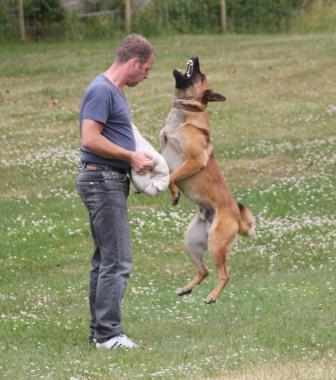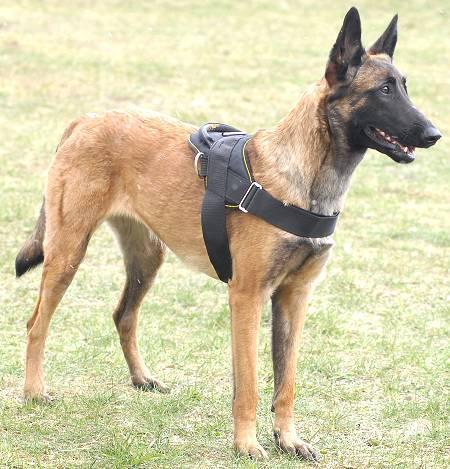The first image is the image on the left, the second image is the image on the right. Considering the images on both sides, is "a dog is laying in the grass with a leash on" valid? Answer yes or no. No. The first image is the image on the left, the second image is the image on the right. Given the left and right images, does the statement "There is a total of 1 German Shepard whose face and body are completely front facing." hold true? Answer yes or no. No. 